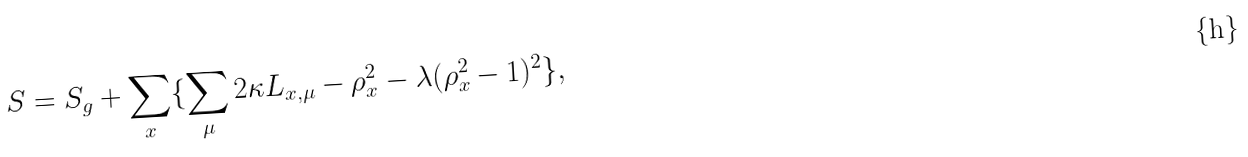<formula> <loc_0><loc_0><loc_500><loc_500>S = S _ { g } + \sum _ { x } \{ \sum _ { \mu } 2 \kappa L _ { x , \mu } - \rho _ { x } ^ { 2 } - \lambda ( \rho _ { x } ^ { 2 } - 1 ) ^ { 2 } \} ,</formula> 